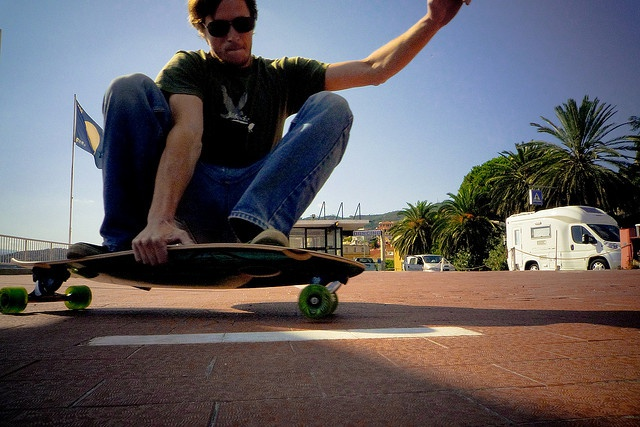Describe the objects in this image and their specific colors. I can see people in gray, black, maroon, and navy tones, skateboard in gray, black, maroon, and olive tones, truck in gray, beige, and black tones, car in gray, black, darkgray, and ivory tones, and car in gray, black, and purple tones in this image. 